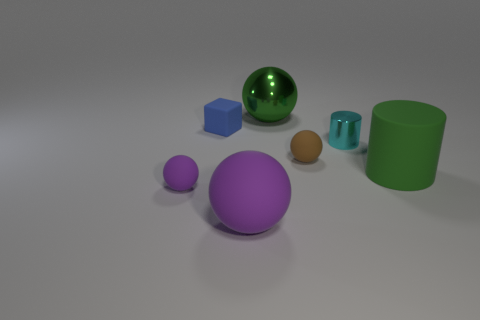Subtract 1 spheres. How many spheres are left? 3 Add 2 cyan rubber cubes. How many objects exist? 9 Subtract all cylinders. How many objects are left? 5 Subtract 0 cyan spheres. How many objects are left? 7 Subtract all green shiny spheres. Subtract all small cyan balls. How many objects are left? 6 Add 5 large purple objects. How many large purple objects are left? 6 Add 7 tiny spheres. How many tiny spheres exist? 9 